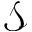<formula> <loc_0><loc_0><loc_500><loc_500>\mathcal { S }</formula> 